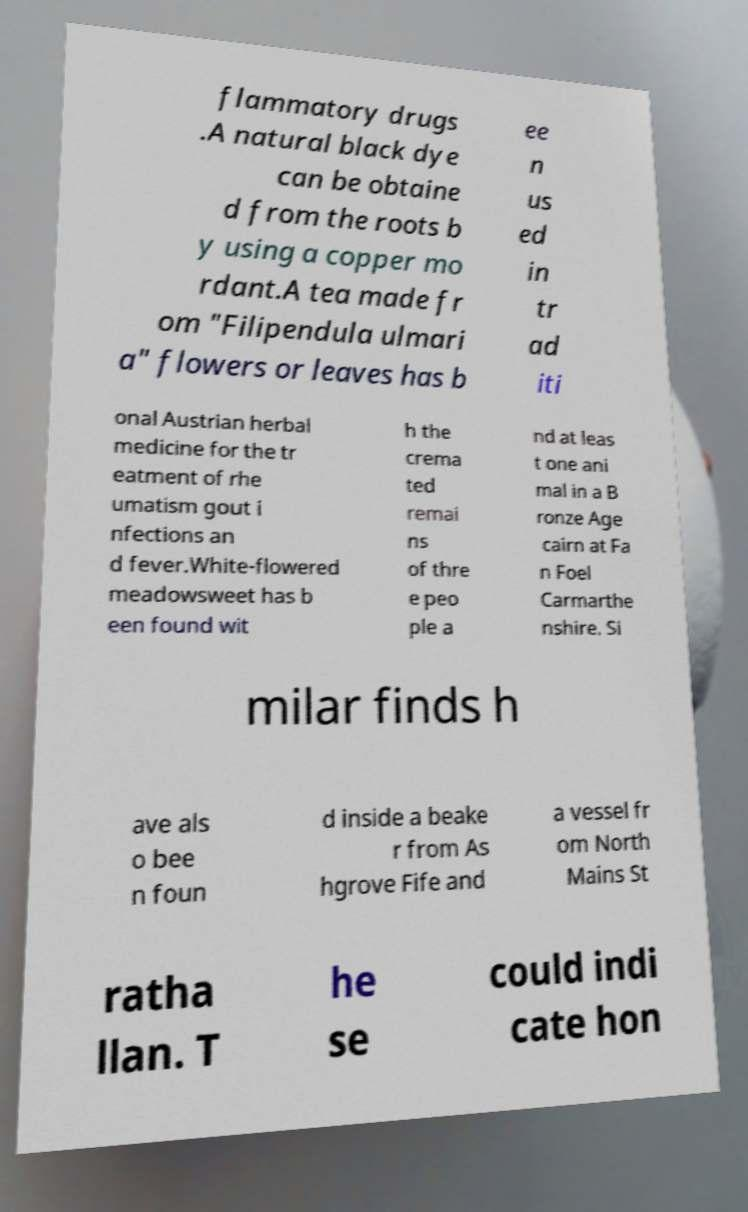Can you accurately transcribe the text from the provided image for me? flammatory drugs .A natural black dye can be obtaine d from the roots b y using a copper mo rdant.A tea made fr om "Filipendula ulmari a" flowers or leaves has b ee n us ed in tr ad iti onal Austrian herbal medicine for the tr eatment of rhe umatism gout i nfections an d fever.White-flowered meadowsweet has b een found wit h the crema ted remai ns of thre e peo ple a nd at leas t one ani mal in a B ronze Age cairn at Fa n Foel Carmarthe nshire. Si milar finds h ave als o bee n foun d inside a beake r from As hgrove Fife and a vessel fr om North Mains St ratha llan. T he se could indi cate hon 